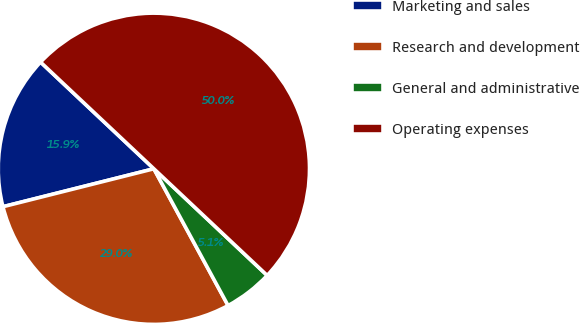Convert chart to OTSL. <chart><loc_0><loc_0><loc_500><loc_500><pie_chart><fcel>Marketing and sales<fcel>Research and development<fcel>General and administrative<fcel>Operating expenses<nl><fcel>15.94%<fcel>28.99%<fcel>5.07%<fcel>50.0%<nl></chart> 